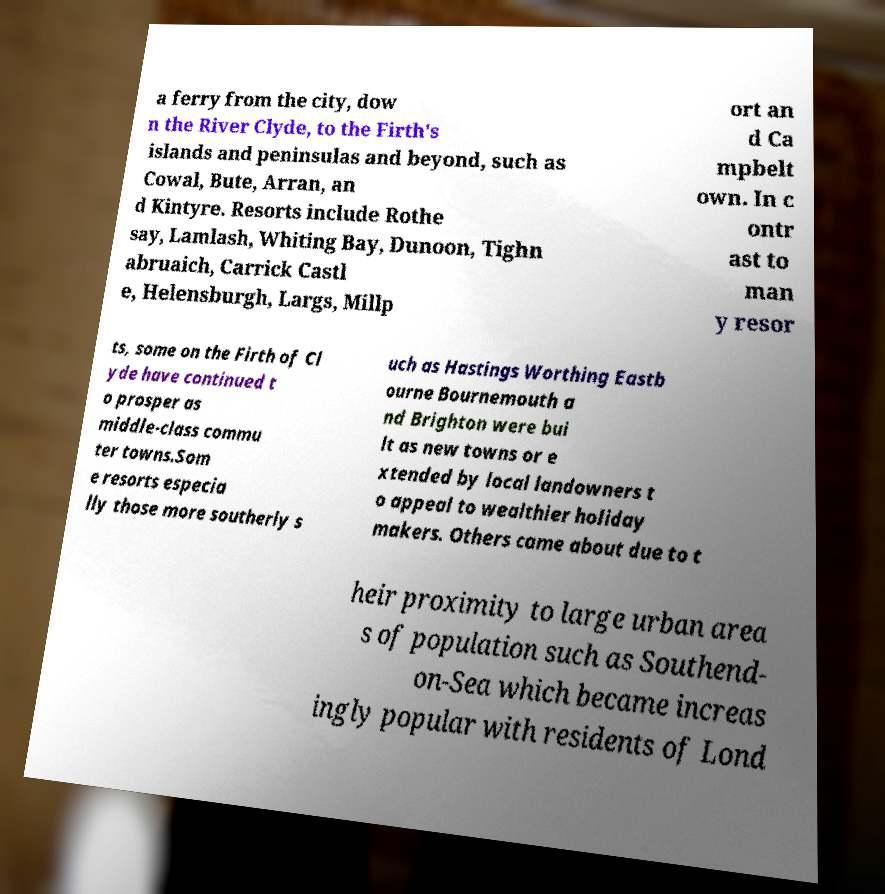I need the written content from this picture converted into text. Can you do that? a ferry from the city, dow n the River Clyde, to the Firth's islands and peninsulas and beyond, such as Cowal, Bute, Arran, an d Kintyre. Resorts include Rothe say, Lamlash, Whiting Bay, Dunoon, Tighn abruaich, Carrick Castl e, Helensburgh, Largs, Millp ort an d Ca mpbelt own. In c ontr ast to man y resor ts, some on the Firth of Cl yde have continued t o prosper as middle-class commu ter towns.Som e resorts especia lly those more southerly s uch as Hastings Worthing Eastb ourne Bournemouth a nd Brighton were bui lt as new towns or e xtended by local landowners t o appeal to wealthier holiday makers. Others came about due to t heir proximity to large urban area s of population such as Southend- on-Sea which became increas ingly popular with residents of Lond 